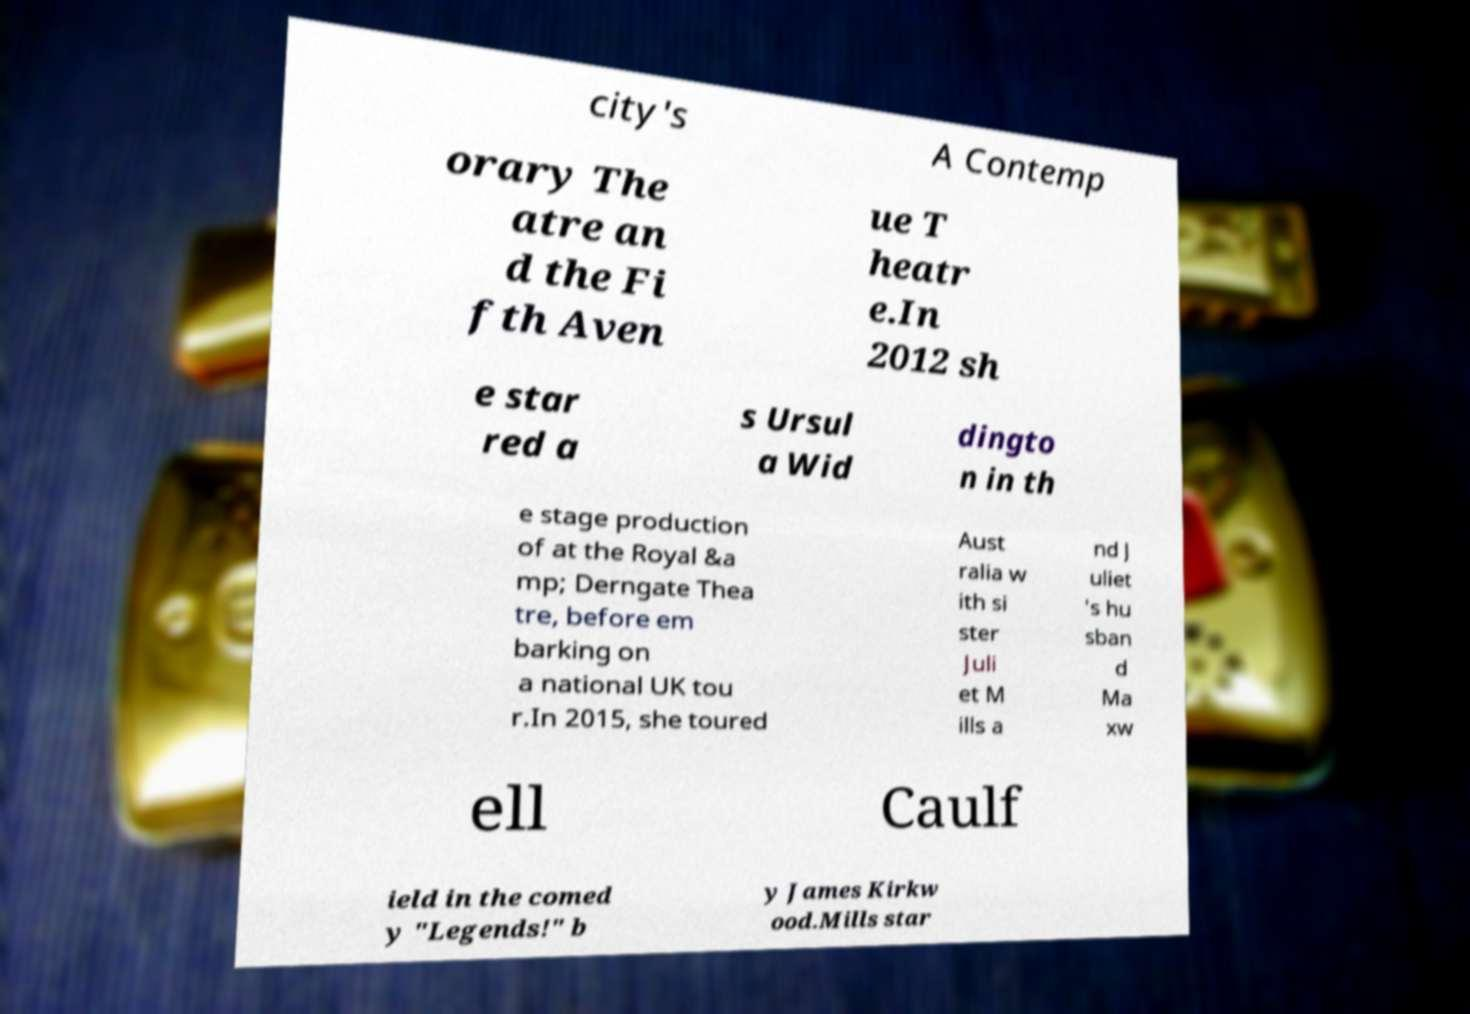There's text embedded in this image that I need extracted. Can you transcribe it verbatim? city's A Contemp orary The atre an d the Fi fth Aven ue T heatr e.In 2012 sh e star red a s Ursul a Wid dingto n in th e stage production of at the Royal &a mp; Derngate Thea tre, before em barking on a national UK tou r.In 2015, she toured Aust ralia w ith si ster Juli et M ills a nd J uliet 's hu sban d Ma xw ell Caulf ield in the comed y "Legends!" b y James Kirkw ood.Mills star 